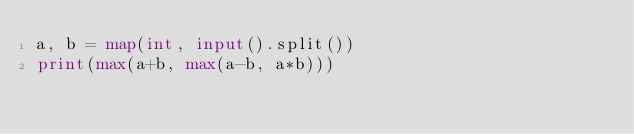<code> <loc_0><loc_0><loc_500><loc_500><_Python_>a, b = map(int, input().split())
print(max(a+b, max(a-b, a*b)))
</code> 